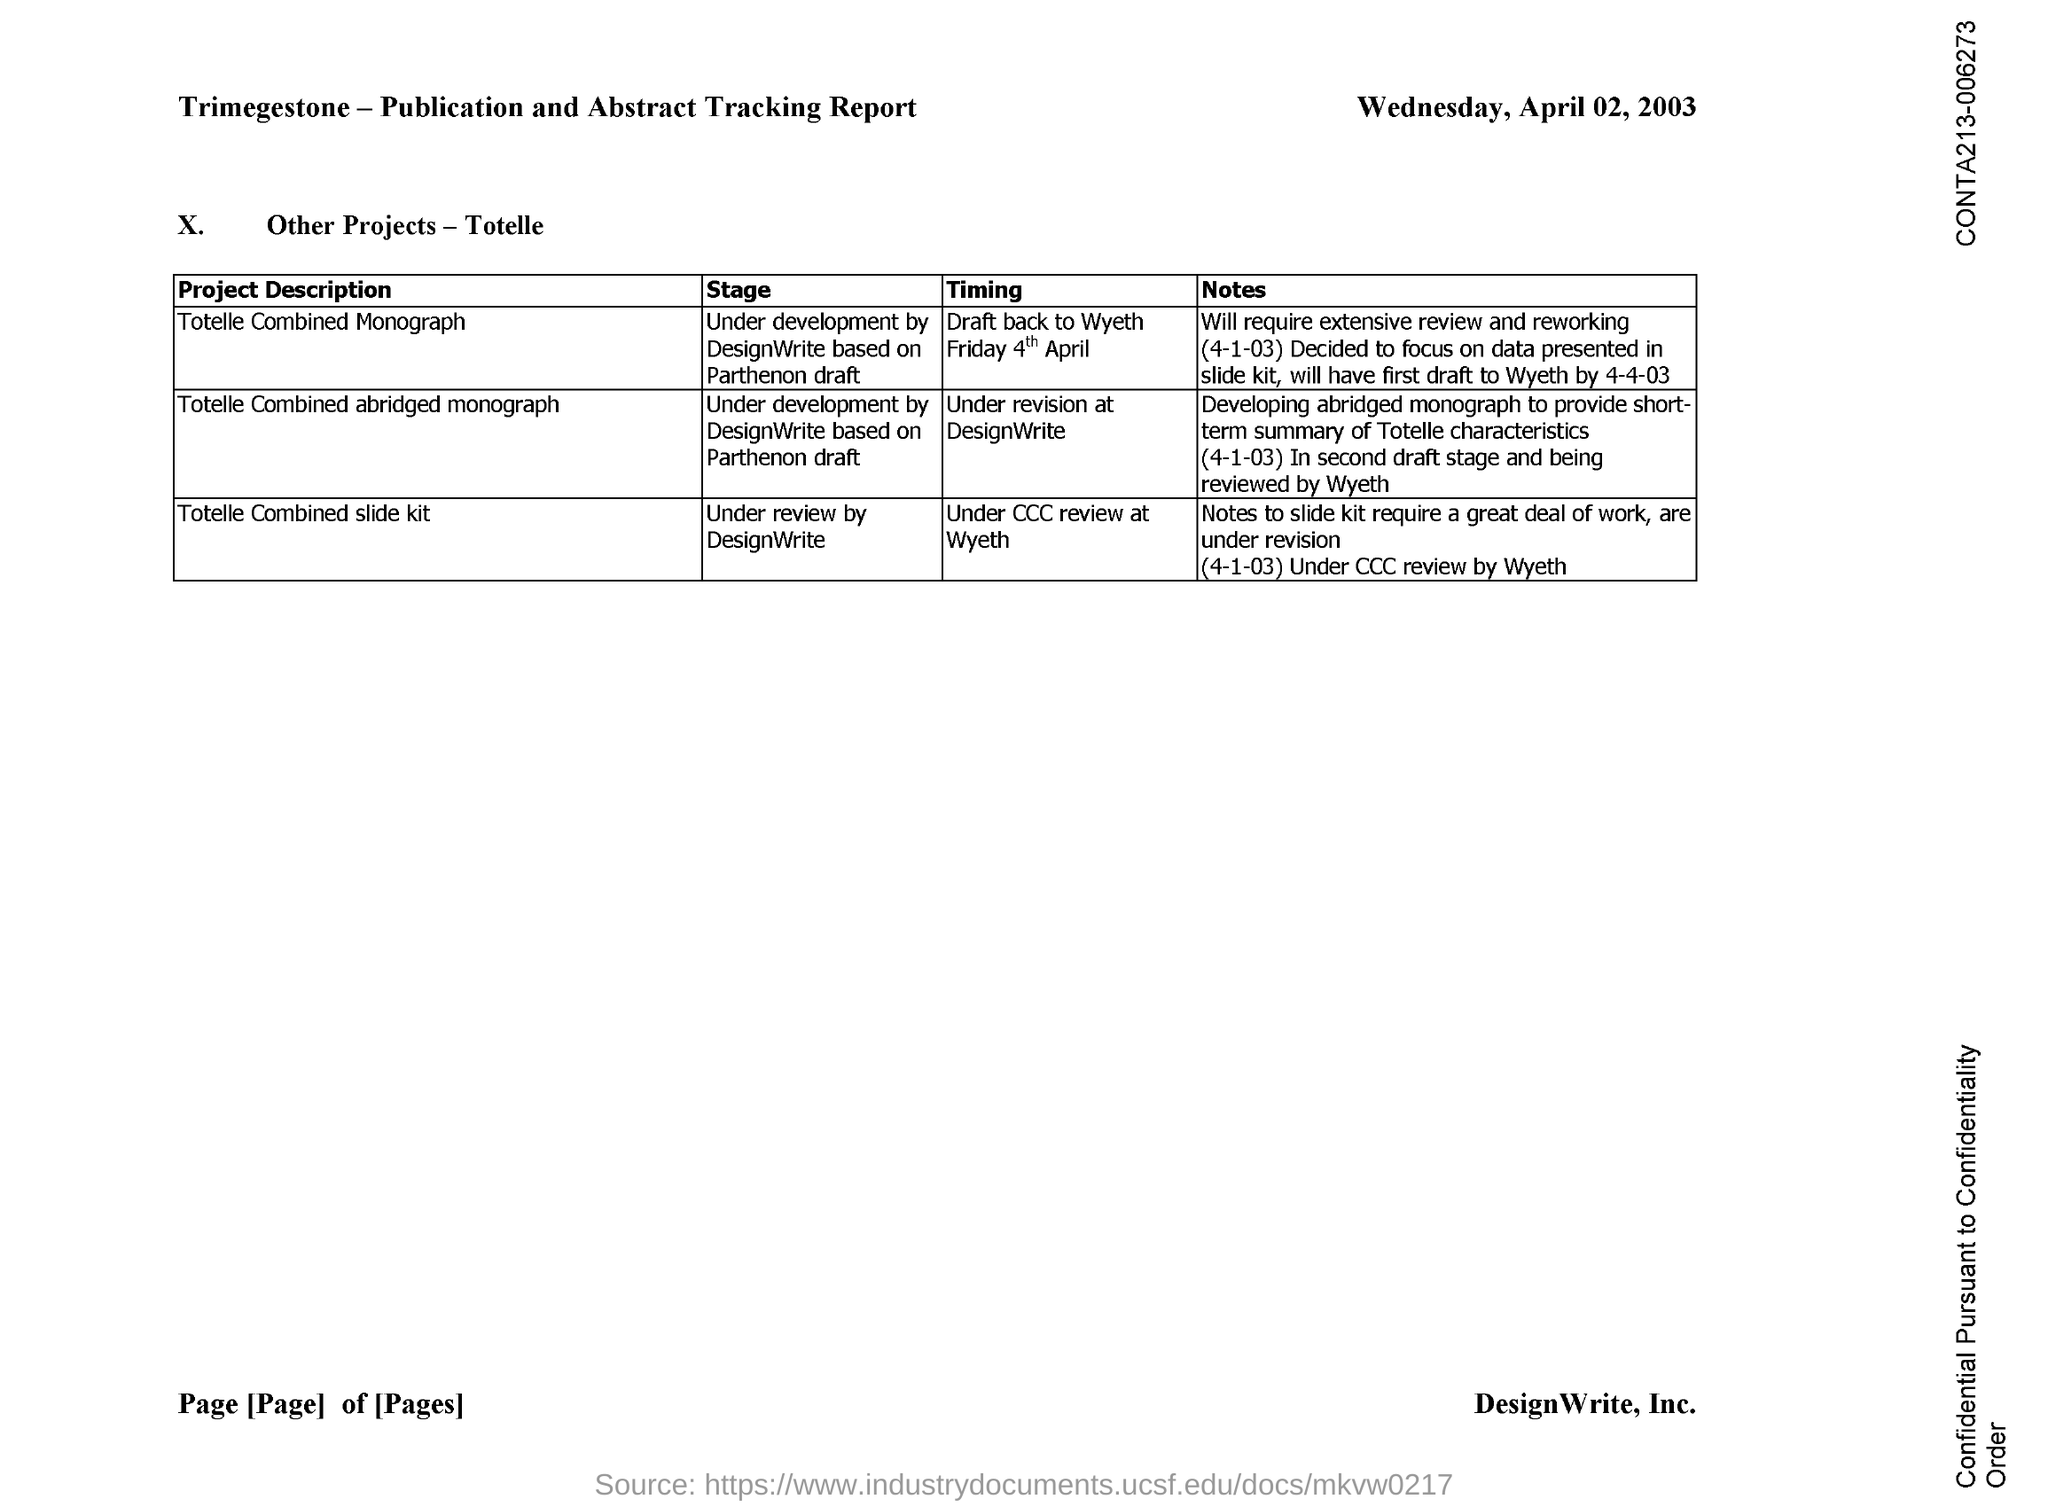In which stage is the Project 'Totelle Combined Monograph'?
Ensure brevity in your answer.  Under development by DesignWrite based on parthenon draft. Which Project is in the stage of under review by DesignWrite?
Keep it short and to the point. Totelle Combined slide kit. 